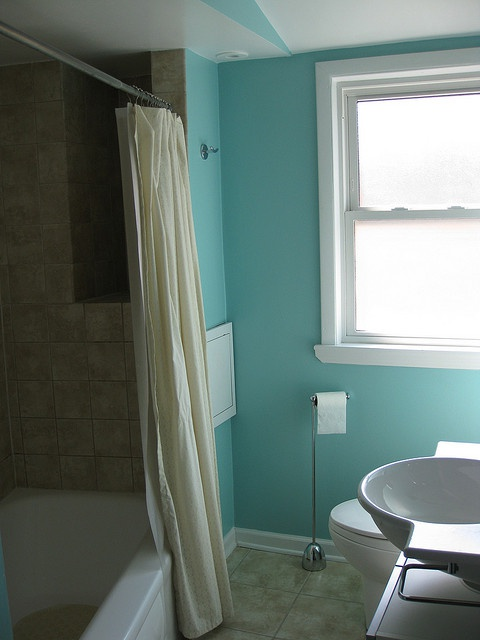Describe the objects in this image and their specific colors. I can see sink in gray, white, and darkgray tones and toilet in gray, lightblue, darkgray, and lightgray tones in this image. 